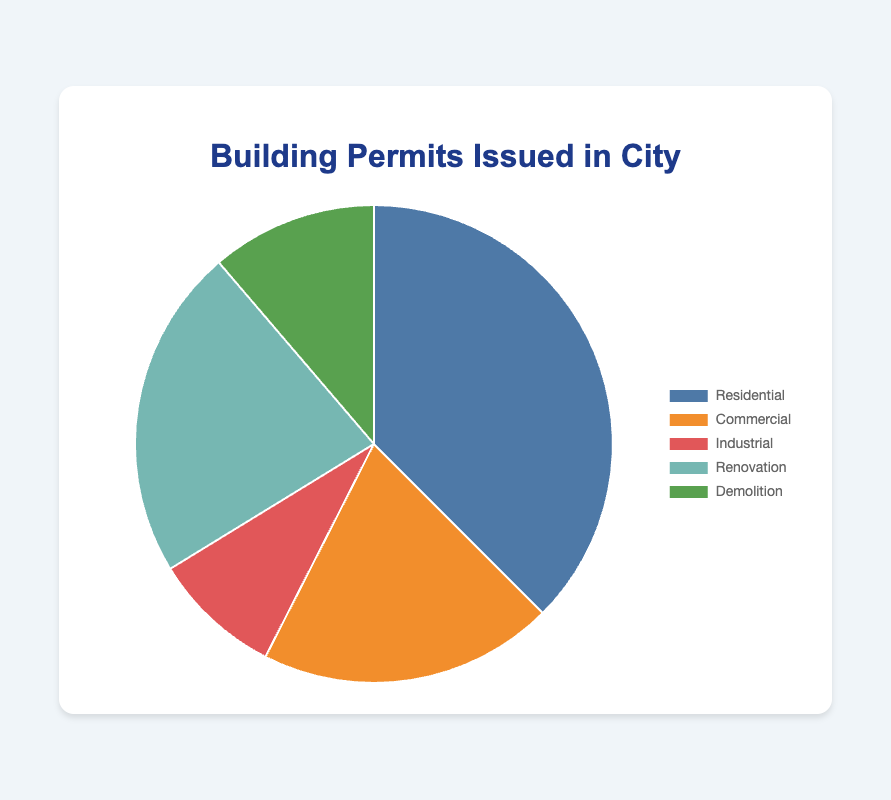What percentage of building permits issued are for Residential purposes? The number of Residential permits is 1500. The total number of permits is 1500 + 800 + 350 + 900 + 450 = 4000. The percentage is (1500 / 4000) * 100 = 37.5%
Answer: 37.5% Which type of permit has the least number of issuances? Among the categories, Industrial has 350 permits, which is the smallest compared to Residential (1500), Commercial (800), Renovation (900), and Demolition (450).
Answer: Industrial How many more Residential permits are issued compared to Industrial permits? The number of Residential permits is 1500 and Industrial permits are 350. The difference is 1500 - 350 = 1150
Answer: 1150 What is the combined percentage of Commercial and Renovation permits issued? The number of Commercial permits is 800 and Renovation permits is 900. The total number of permits issued is 4000. The combined permits are 800 + 900 = 1700. The combined percentage is (1700 / 4000) * 100 = 42.5%
Answer: 42.5% If you were to group Industrial and Demolition permits together, would that combined category exceed the number of Residential permits? The number of Industrial permits is 350 and Demolition permits is 450. Their combined total is 350 + 450 = 800, which is less than the number of Residential permits (1500).
Answer: No Which color represents the Renovation permits in the pie chart? Renovation permits are represented by the third color, which is mentioned as '#76b7b2'. This corresponds to a greenish-blue color on the pie chart.
Answer: Greenish-blue What is the difference in percentage between the highest and lowest categories of permits? The highest category is Residential with 1500 permits, representing (1500/4000)*100 = 37.5%. The lowest category is Industrial with 350 permits, representing (350/4000)*100 = 8.75%. The difference is 37.5% - 8.75% = 28.75%.
Answer: 28.75% If 200 more Residential permits were issued, what would be the new percentage of Residential permits? Initially, there were 1500 Residential permits. Adding 200 more makes it 1700. The new total permits are 4000 + 200 = 4200. The new percentage is (1700 / 4200) * 100 = 40.48%.
Answer: 40.48% Which permit type is represented by the color closest to orange? The color closest to orange in the pie chart represents Commercial permits.
Answer: Commercial What is the ratio of Renovation permits to Demolition permits? The number of Renovation permits is 900, and the number of Demolition permits is 450. The ratio of Renovation to Demolition permits is 900:450, which simplifies to 2:1.
Answer: 2:1 